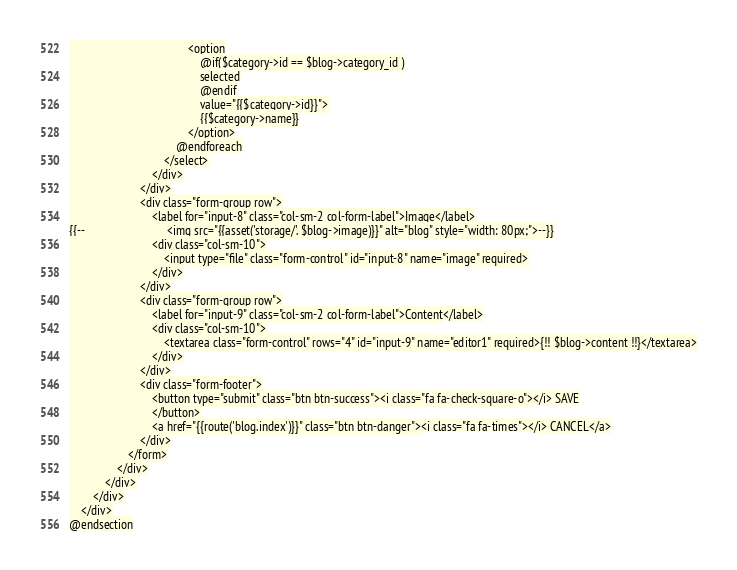Convert code to text. <code><loc_0><loc_0><loc_500><loc_500><_PHP_>                                        <option
                                            @if($category->id == $blog->category_id )
                                            selected
                                            @endif
                                            value="{{$category->id}}">
                                            {{$category->name}}
                                        </option>
                                    @endforeach
                                </select>
                            </div>
                        </div>
                        <div class="form-group row">
                            <label for="input-8" class="col-sm-2 col-form-label">Image</label>
{{--                            <img src="{{asset('storage/'. $blog->image)}}" alt="blog" style="width: 80px;">--}}
                            <div class="col-sm-10">
                                <input type="file" class="form-control" id="input-8" name="image" required>
                            </div>
                        </div>
                        <div class="form-group row">
                            <label for="input-9" class="col-sm-2 col-form-label">Content</label>
                            <div class="col-sm-10">
                                <textarea class="form-control" rows="4" id="input-9" name="editor1" required>{!! $blog->content !!}</textarea>
                            </div>
                        </div>
                        <div class="form-footer">
                            <button type="submit" class="btn btn-success"><i class="fa fa-check-square-o"></i> SAVE
                            </button>
                            <a href="{{route('blog.index')}}" class="btn btn-danger"><i class="fa fa-times"></i> CANCEL</a>
                        </div>
                    </form>
                </div>
            </div>
        </div>
    </div>
@endsection
</code> 